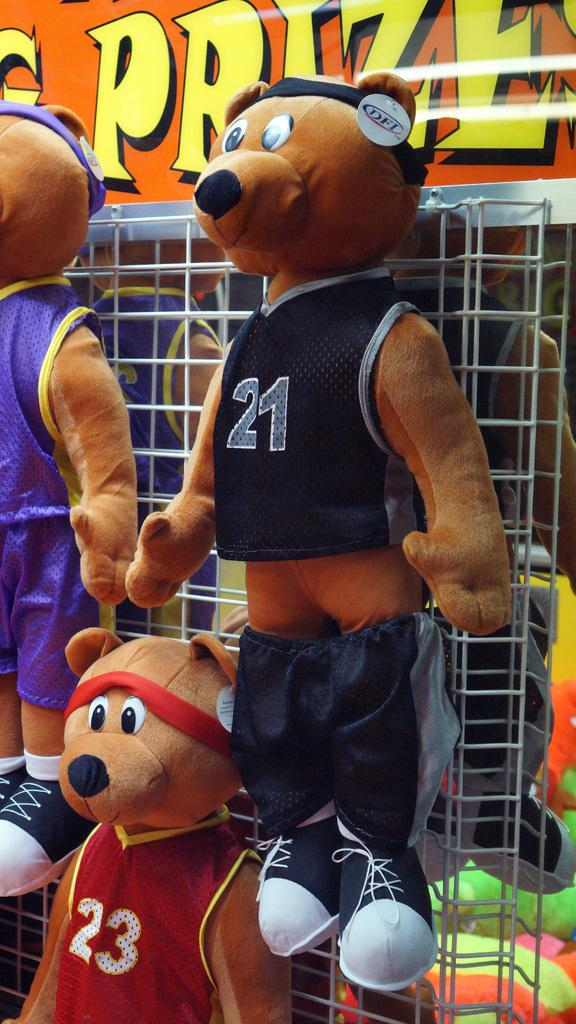<image>
Describe the image concisely. a stuffed animal with the number 21 on it 